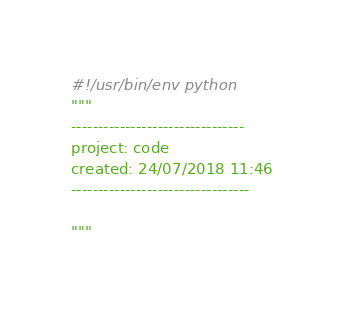Convert code to text. <code><loc_0><loc_0><loc_500><loc_500><_Python_>#!/usr/bin/env python
"""
--------------------------------
project: code
created: 24/07/2018 11:46
---------------------------------

"""
</code> 